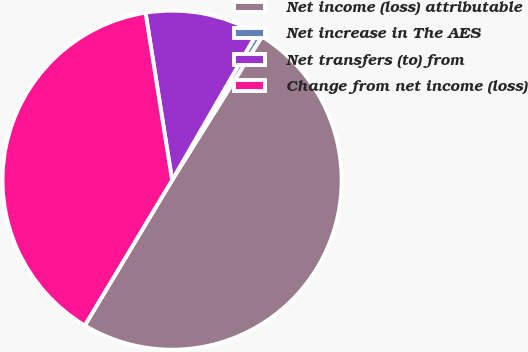Convert chart. <chart><loc_0><loc_0><loc_500><loc_500><pie_chart><fcel>Net income (loss) attributable<fcel>Net increase in The AES<fcel>Net transfers (to) from<fcel>Change from net income (loss)<nl><fcel>49.72%<fcel>0.56%<fcel>10.84%<fcel>38.89%<nl></chart> 